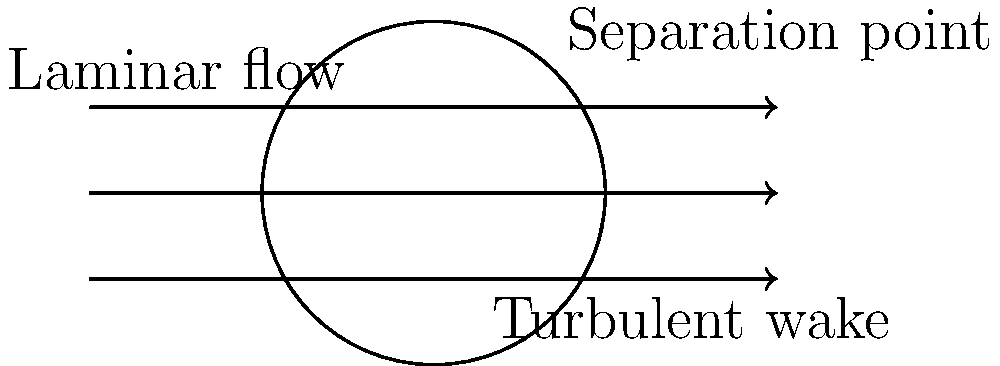As a professional soccer player, understanding ball aerodynamics is crucial. In the diagram, which shows the air flow around a soccer ball in flight, what does the dashed line on the ball's surface represent, and how does it affect the ball's trajectory? To understand the aerodynamics of a soccer ball in flight:

1. Observe the air flow lines: They show smooth flow (laminar) on the front of the ball and disrupted flow (turbulent) behind it.

2. Identify the dashed line: This represents the separation point, where the airflow detaches from the ball's surface.

3. Understand separation point importance:
   a) It determines the size of the wake (turbulent area) behind the ball.
   b) The wake size affects air pressure distribution around the ball.

4. Consider the effect on trajectory:
   a) A larger wake (early separation) increases air resistance, slowing the ball.
   b) A smaller wake (late separation) reduces air resistance, allowing the ball to travel farther.

5. Relate to ball design:
   a) Smooth balls have earlier separation, creating larger wakes and more drag.
   b) Textured or dimpled balls delay separation, reducing drag and potentially increasing distance.

6. Impact on player technique:
   a) Striking the ball to induce spin can alter the separation point location.
   b) This creates uneven air pressure, leading to curved trajectories (e.g., bend it like Beckham).

The separation point is crucial in determining a soccer ball's flight characteristics, affecting both distance and trajectory.
Answer: Separation point; delays separation, reduces drag, increases distance, and enables curved trajectories when spin is applied. 